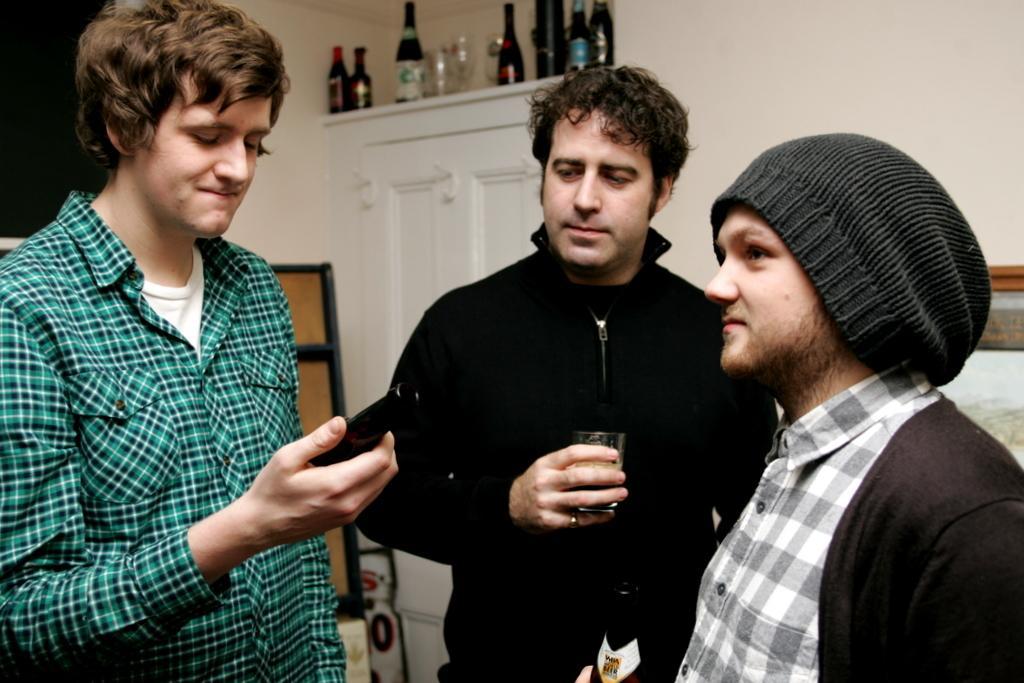How would you summarize this image in a sentence or two? In this image there are three men standing. The man in the center is holding a glass in his hand. The other two are holding bottles in their hands. Behind them there is a cupboard. There are bottles and glasses on the cupboard. In the top right there is a wall. 